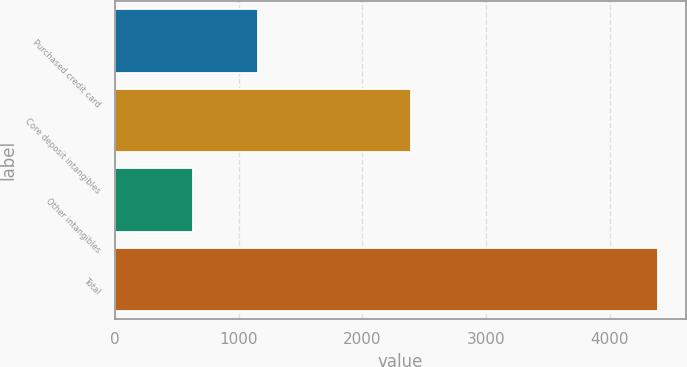<chart> <loc_0><loc_0><loc_500><loc_500><bar_chart><fcel>Purchased credit card<fcel>Core deposit intangibles<fcel>Other intangibles<fcel>Total<nl><fcel>1159<fcel>2396<fcel>633<fcel>4393<nl></chart> 